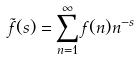Convert formula to latex. <formula><loc_0><loc_0><loc_500><loc_500>\tilde { f } ( s ) = \sum _ { n = 1 } ^ { \infty } f ( n ) n ^ { - s }</formula> 